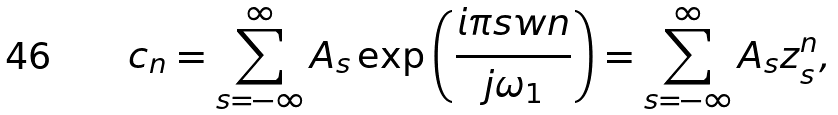Convert formula to latex. <formula><loc_0><loc_0><loc_500><loc_500>c _ { n } = \sum _ { s = - \infty } ^ { \infty } A _ { s } \exp \left ( \frac { i \pi s w n } { j \omega _ { 1 } } \right ) = \sum _ { s = - \infty } ^ { \infty } A _ { s } z _ { s } ^ { n } ,</formula> 